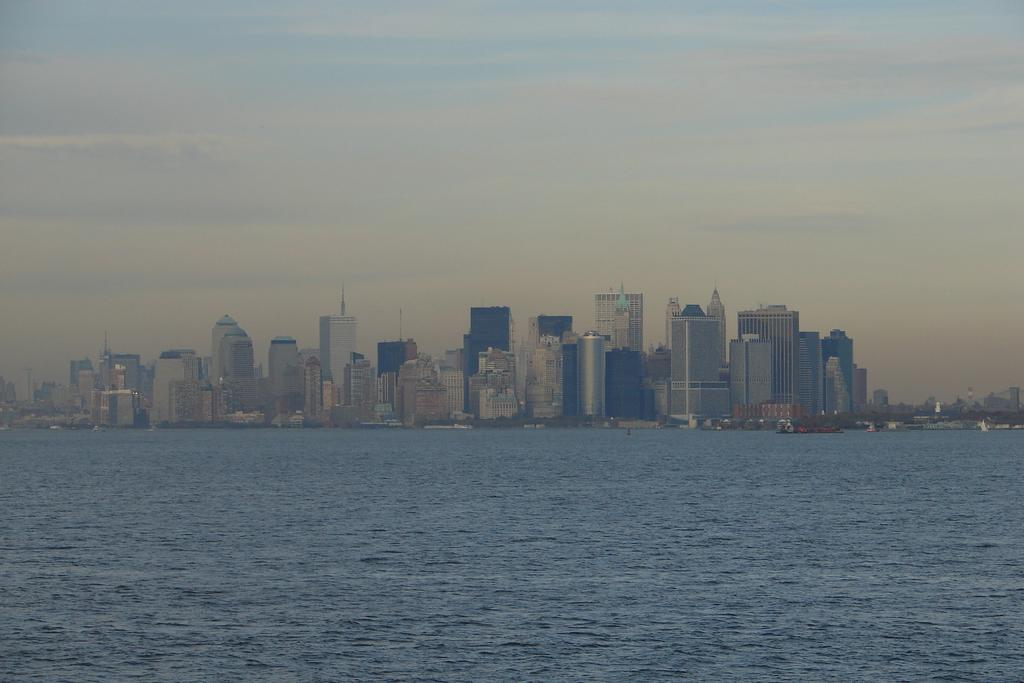What is visible in the image? Water is visible in the image. What can be seen in the distance in the image? There are buildings in the background of the image. What is the condition of the sky in the image? The sky is clear and visible in the background of the image. Can you see a woman tying a knot in the picture? There is no woman or knot present in the image. 